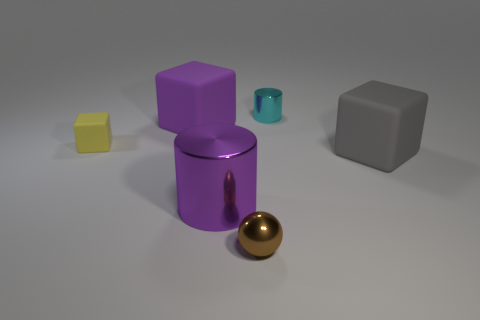Are there any other things that are the same size as the yellow object?
Your answer should be compact. Yes. There is a large purple thing that is the same shape as the yellow rubber object; what material is it?
Offer a terse response. Rubber. What is the shape of the big object on the left side of the shiny object to the left of the small brown shiny object?
Make the answer very short. Cube. Are the cylinder that is in front of the cyan metal thing and the gray object made of the same material?
Provide a short and direct response. No. Is the number of yellow things that are to the right of the tiny brown metal ball the same as the number of purple matte objects that are in front of the large metal thing?
Offer a very short reply. Yes. There is a thing that is the same color as the big cylinder; what material is it?
Offer a terse response. Rubber. There is a big object on the left side of the large purple cylinder; what number of spheres are behind it?
Keep it short and to the point. 0. Do the large object that is to the right of the ball and the cylinder in front of the small cyan thing have the same color?
Make the answer very short. No. What material is the purple cylinder that is the same size as the gray thing?
Offer a very short reply. Metal. The small metallic object that is behind the big block behind the big rubber cube that is right of the small metal cylinder is what shape?
Keep it short and to the point. Cylinder. 